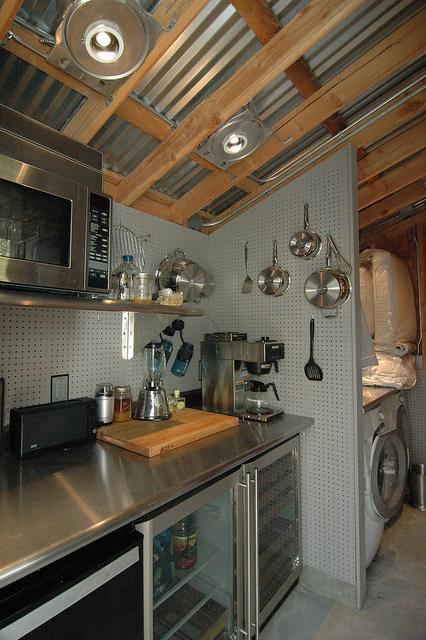Is there a stainless steel microwave on the shelf?
Concise answer only. Yes. Is this a bakery?
Answer briefly. No. Has the kitchen been cleaned?
Quick response, please. Yes. Are the pots and pans stacked together?
Concise answer only. No. Is this a house?
Answer briefly. Yes. 